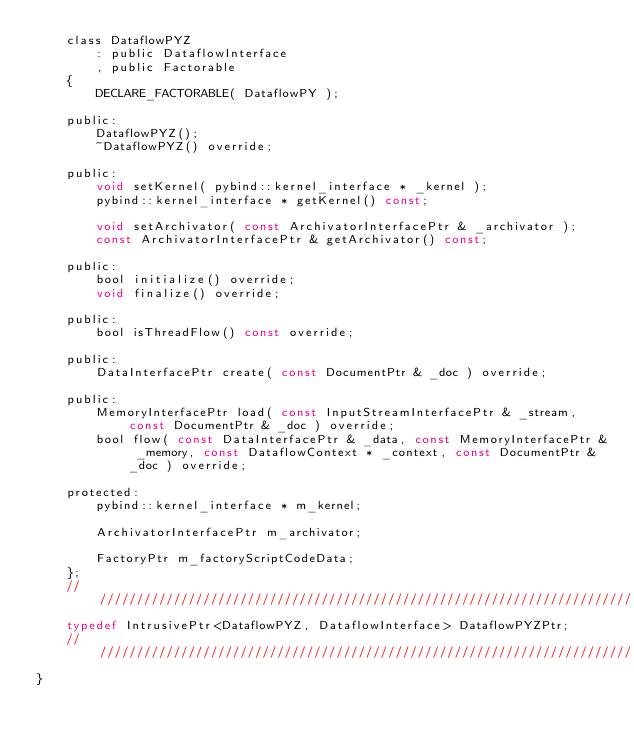Convert code to text. <code><loc_0><loc_0><loc_500><loc_500><_C_>    class DataflowPYZ
        : public DataflowInterface
        , public Factorable
    {
        DECLARE_FACTORABLE( DataflowPY );

    public:
        DataflowPYZ();
        ~DataflowPYZ() override;

    public:
        void setKernel( pybind::kernel_interface * _kernel );
        pybind::kernel_interface * getKernel() const;

        void setArchivator( const ArchivatorInterfacePtr & _archivator );
        const ArchivatorInterfacePtr & getArchivator() const;

    public:
        bool initialize() override;
        void finalize() override;

    public:
        bool isThreadFlow() const override;

    public:
        DataInterfacePtr create( const DocumentPtr & _doc ) override;

    public:
        MemoryInterfacePtr load( const InputStreamInterfacePtr & _stream, const DocumentPtr & _doc ) override;
        bool flow( const DataInterfacePtr & _data, const MemoryInterfacePtr & _memory, const DataflowContext * _context, const DocumentPtr & _doc ) override;

    protected:
        pybind::kernel_interface * m_kernel;

        ArchivatorInterfacePtr m_archivator;

        FactoryPtr m_factoryScriptCodeData;
    };
    //////////////////////////////////////////////////////////////////////////
    typedef IntrusivePtr<DataflowPYZ, DataflowInterface> DataflowPYZPtr;
    //////////////////////////////////////////////////////////////////////////
}</code> 